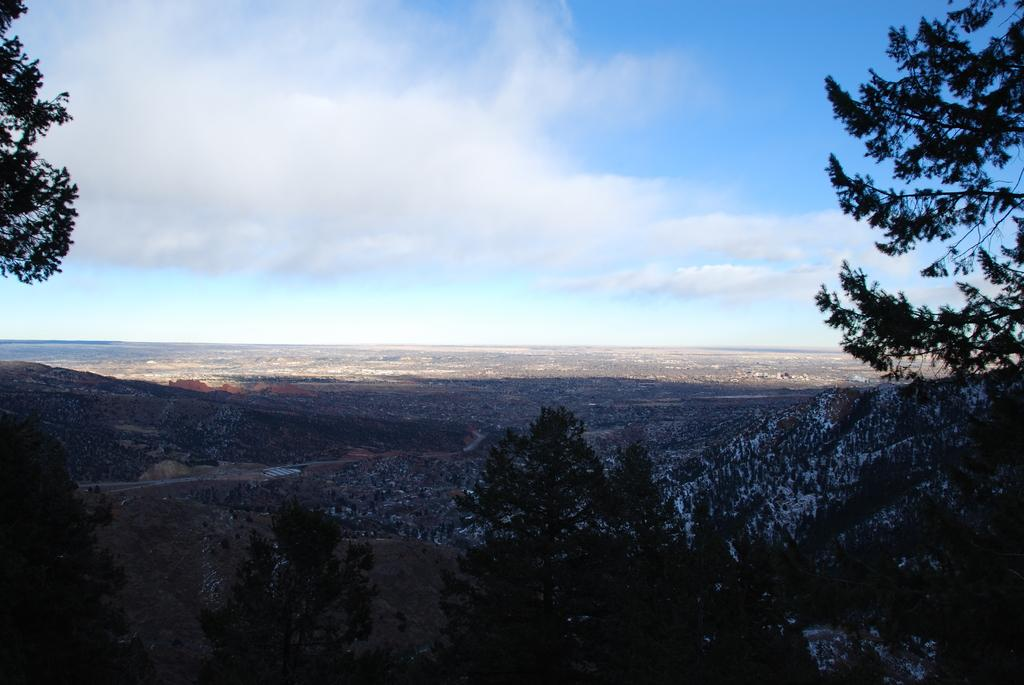What type of vegetation is visible in the front of the image? There are trees in the front of the image. What is visible at the top of the image? The sky is visible at the top of the image. What type of underwear is hanging on the trees in the image? There is no underwear present in the image; it only features trees and the sky. How is the oatmeal being used in the image? There is no oatmeal present in the image. 